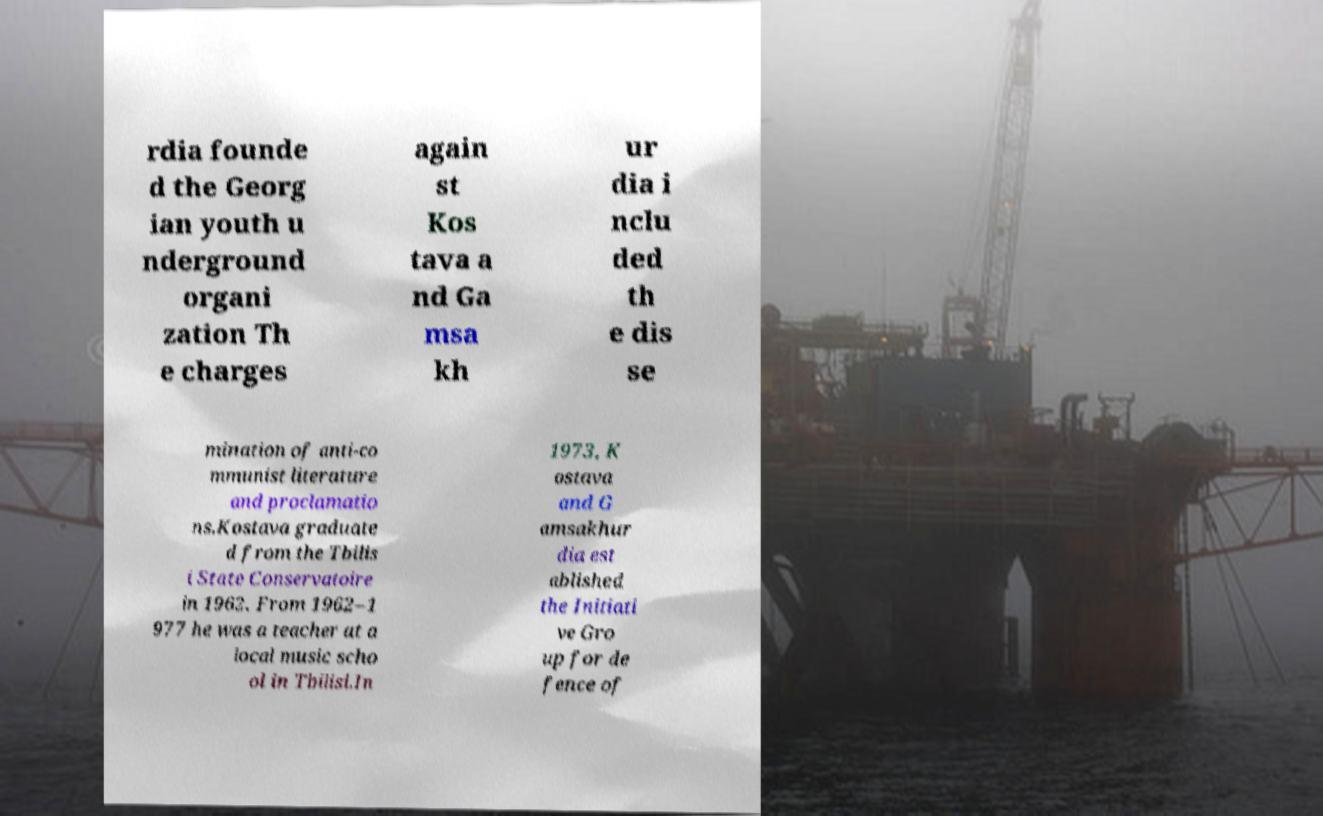For documentation purposes, I need the text within this image transcribed. Could you provide that? rdia founde d the Georg ian youth u nderground organi zation Th e charges again st Kos tava a nd Ga msa kh ur dia i nclu ded th e dis se mination of anti-co mmunist literature and proclamatio ns.Kostava graduate d from the Tbilis i State Conservatoire in 1962. From 1962–1 977 he was a teacher at a local music scho ol in Tbilisi.In 1973, K ostava and G amsakhur dia est ablished the Initiati ve Gro up for de fence of 